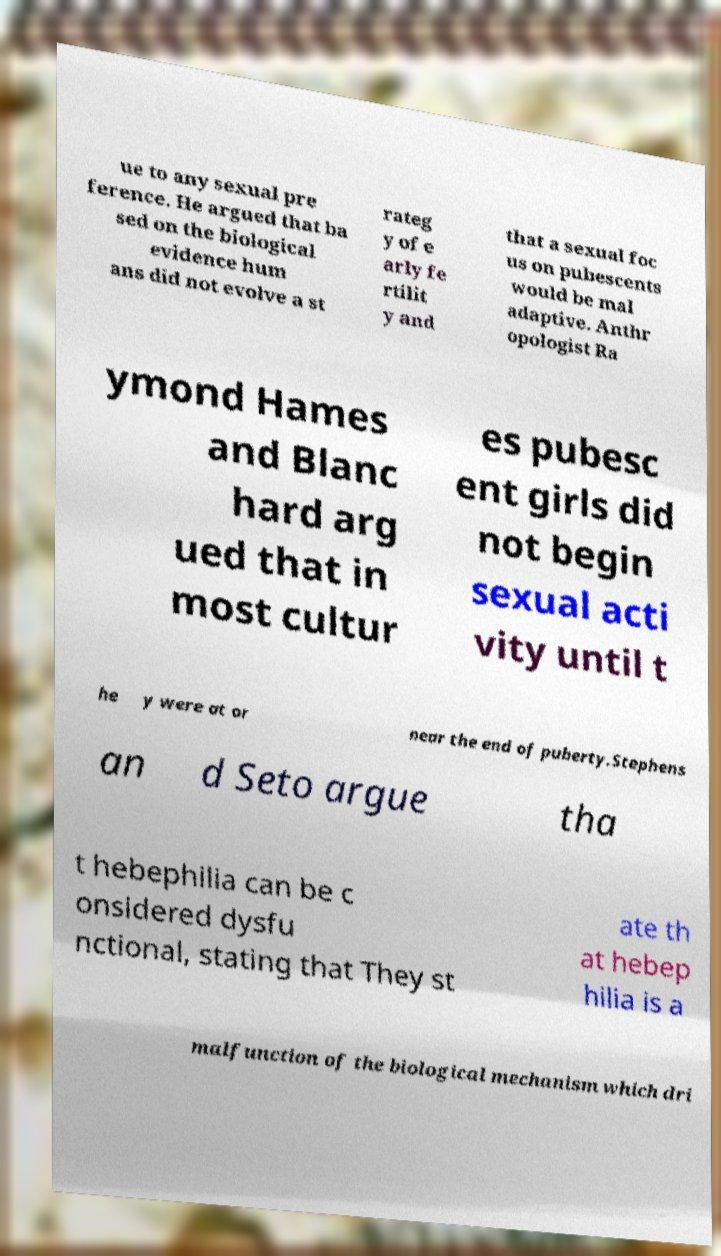There's text embedded in this image that I need extracted. Can you transcribe it verbatim? ue to any sexual pre ference. He argued that ba sed on the biological evidence hum ans did not evolve a st rateg y of e arly fe rtilit y and that a sexual foc us on pubescents would be mal adaptive. Anthr opologist Ra ymond Hames and Blanc hard arg ued that in most cultur es pubesc ent girls did not begin sexual acti vity until t he y were at or near the end of puberty.Stephens an d Seto argue tha t hebephilia can be c onsidered dysfu nctional, stating that They st ate th at hebep hilia is a malfunction of the biological mechanism which dri 